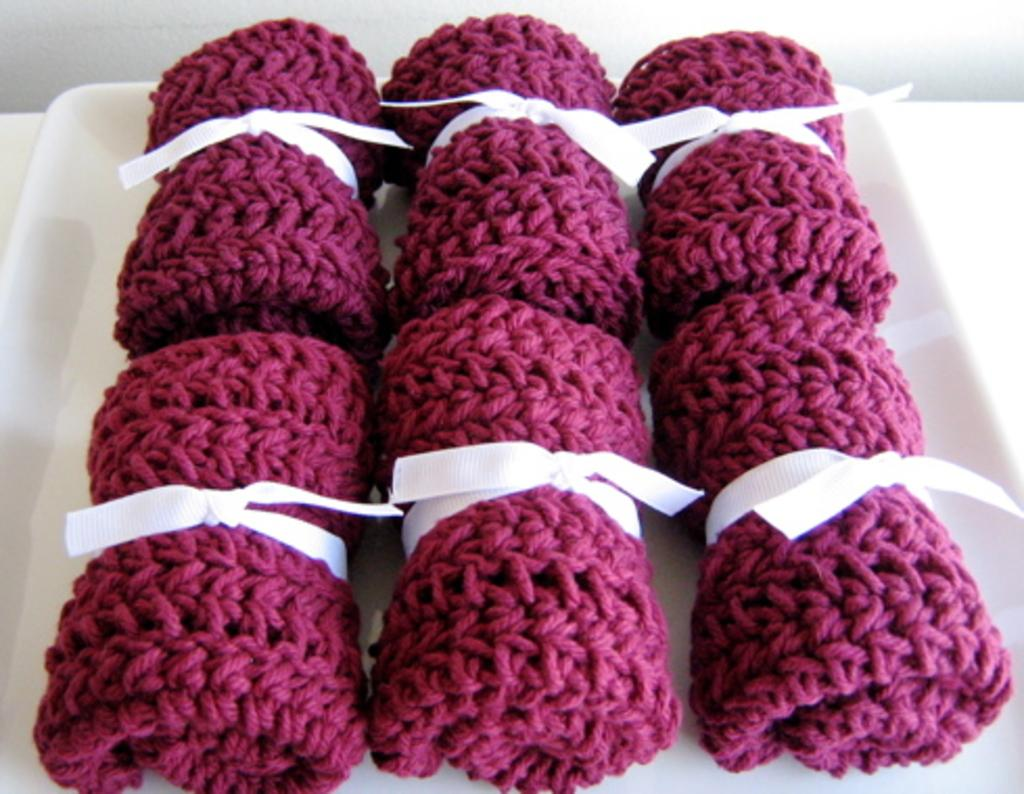What type of objects are in the image? There are crochets in the image. Where are the crochets located? The crochets are in a plate. What type of clothing is the scarecrow wearing in the image? There is no scarecrow present in the image, so it is not possible to determine what clothing it might be wearing. 